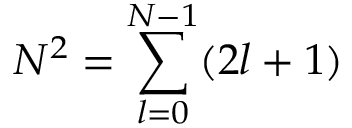<formula> <loc_0><loc_0><loc_500><loc_500>N ^ { 2 } = \sum _ { l = 0 } ^ { N - 1 } ( 2 l + 1 )</formula> 